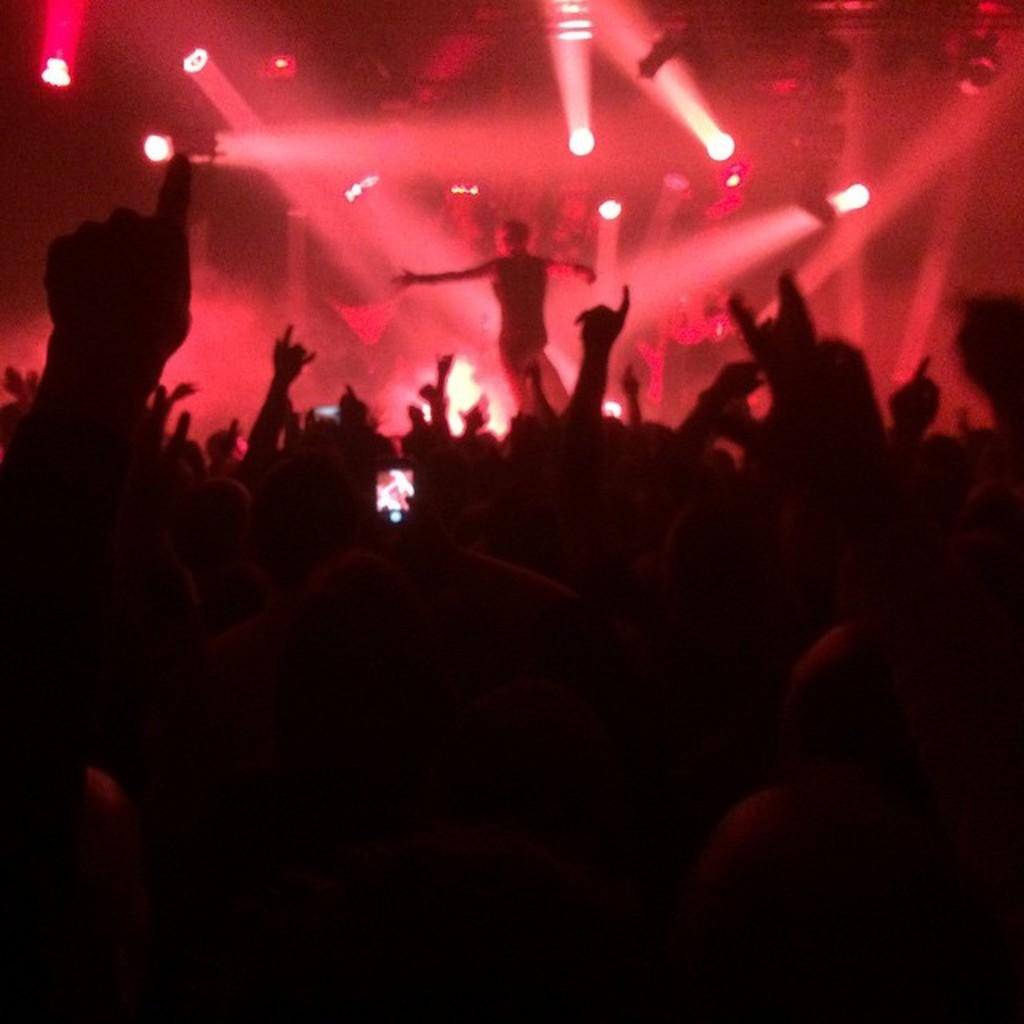What is the main subject of the image? The main subject of the image is people in the center. Can you describe the background of the image? There are lights in the background of the image. What type of stocking is the person wearing on their neck in the image? There is no person wearing stockings on their neck in the image. Who is the father of the person in the image? There is no information about a father or any family relationships in the image. 